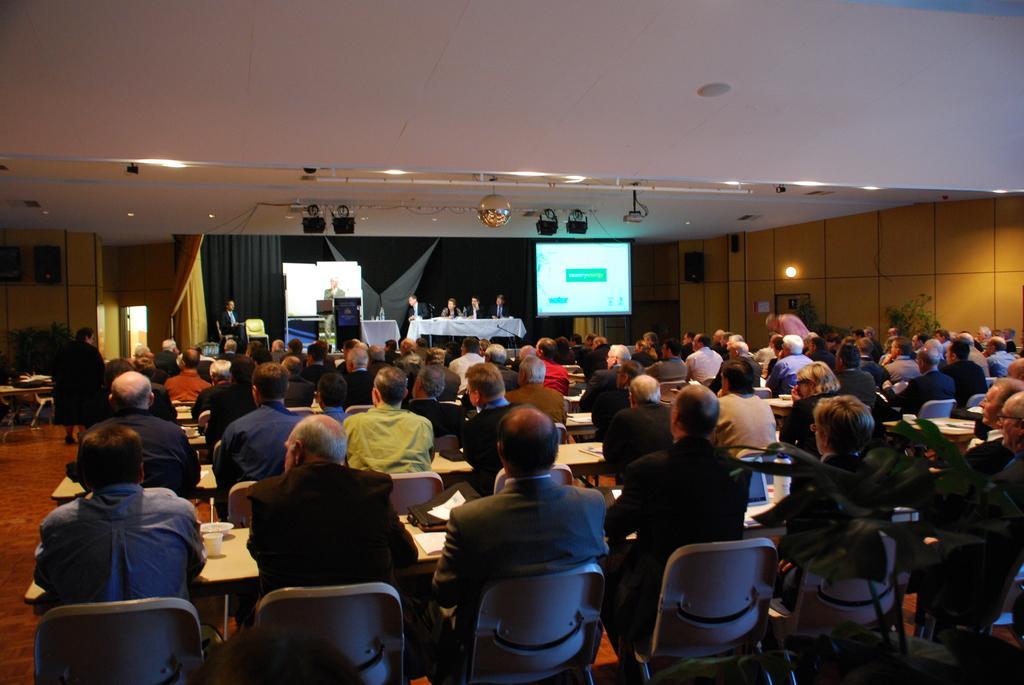How would you summarize this image in a sentence or two? Here we can see a group of people sitting on chairs with tables in front of them probably attending a meeting and in front of them we can see some people sitting and a person standing giving a speech and there is a projector screen present and there are lights here and there 